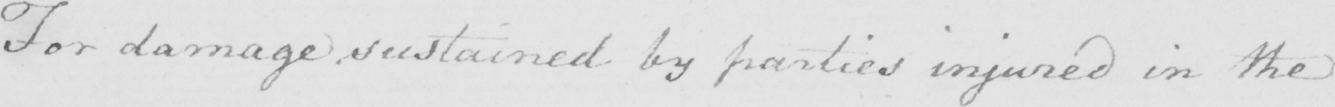Transcribe the text shown in this historical manuscript line. For damage sustained by parties injured in the 